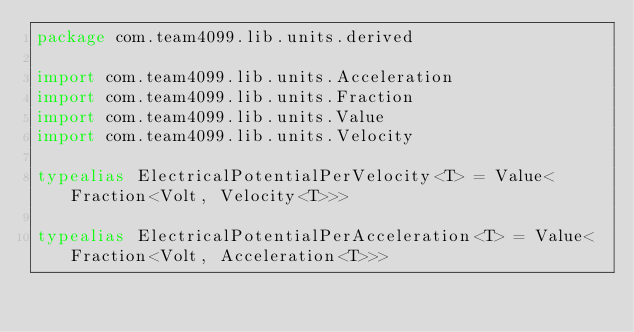Convert code to text. <code><loc_0><loc_0><loc_500><loc_500><_Kotlin_>package com.team4099.lib.units.derived

import com.team4099.lib.units.Acceleration
import com.team4099.lib.units.Fraction
import com.team4099.lib.units.Value
import com.team4099.lib.units.Velocity

typealias ElectricalPotentialPerVelocity<T> = Value<Fraction<Volt, Velocity<T>>>

typealias ElectricalPotentialPerAcceleration<T> = Value<Fraction<Volt, Acceleration<T>>>
</code> 